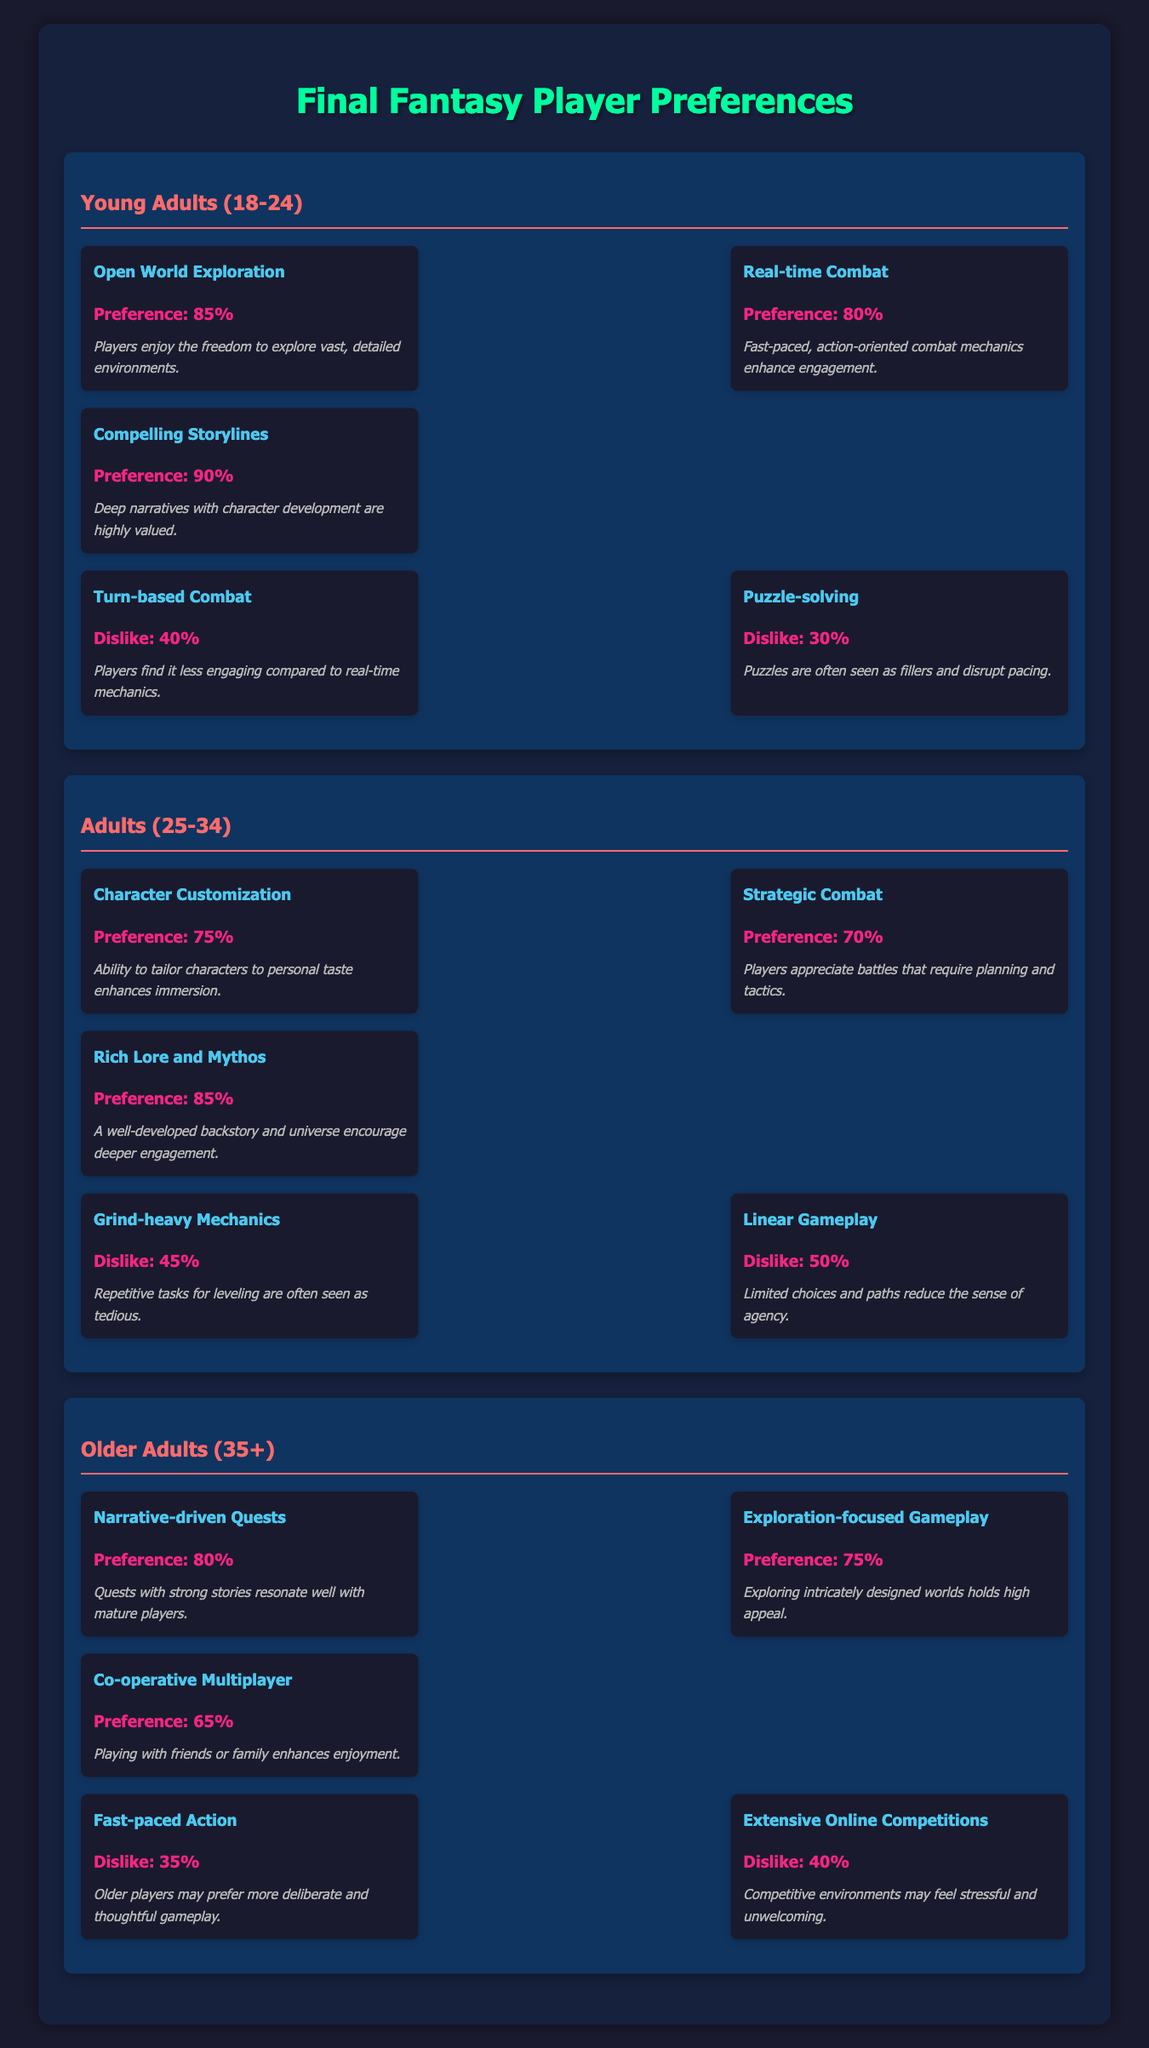What's the preference score for "Compelling Storylines" among Young Adults (18-24)? The table shows that under the Young Adults (18-24) demographic, the preference score for "Compelling Storylines" is listed as 90%.
Answer: 90% Which feature do Older Adults (35+) dislike the most based on the dislike scores? According to the table, the feature with the highest dislike score among Older Adults (35+) is "Extensive Online Competitions" with a dislike score of 40%.
Answer: "Extensive Online Competitions" What are the top three mechanics preferred by Adults (25-34)? The table indicates that the top three mechanics for Adults (25-34) are "Rich Lore and Mythos" (85%), "Character Customization" (75%), and "Strategic Combat" (70%).
Answer: "Rich Lore and Mythos", "Character Customization", "Strategic Combat" Calculate the average preference score for the top mechanics among Young Adults (18-24). The top mechanics for Young Adults (18-24) are "Open World Exploration" (85), "Real-time Combat" (80), and "Compelling Storylines" (90). To find the average, add these scores: (85 + 80 + 90) = 255. Then divide by 3 (the number of mechanics), which gives 255/3 = 85.
Answer: 85 Do Adults (25-34) prefer "Grind-heavy Mechanics" over "Linear Gameplay"? The dislike score for "Grind-heavy Mechanics" is 45%, while "Linear Gameplay" has a higher dislike score of 50%. Since players dislike a higher score more, this means they prefer "Grind-heavy Mechanics" over "Linear Gameplay".
Answer: Yes Which player demographic has the highest preference score for exploration-focused gameplay? The table shows "Exploration-focused Gameplay" has a preference score of 75% under Older Adults (35+), which is the highest score for this mechanic compared to other demographics that do not list this mechanic.
Answer: Older Adults (35+) What is the difference in dislike scores between "Turn-based Combat" and "Puzzle-solving" for Young Adults (18-24)? The dislike score for "Turn-based Combat" is 40%, and for "Puzzle-solving," it is 30%. To find the difference, subtract: 40 - 30 = 10.
Answer: 10 Which player demographic has a preference for "Co-operative Multiplayer"? The table indicates that only Older Adults (35+) express a preference for "Co-operative Multiplayer," as it's listed among their top mechanics with a preference score of 65%.
Answer: Older Adults (35+) 